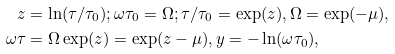<formula> <loc_0><loc_0><loc_500><loc_500>z & = \ln ( \tau / \tau _ { 0 } ) ; \omega \tau _ { 0 } = \Omega ; \tau / \tau _ { 0 } = \exp ( z ) , \Omega = \exp ( - \mu ) , \\ \omega \tau & = \Omega \exp ( z ) = \exp ( z - \mu ) , y = - \ln ( \omega \tau _ { 0 } ) ,</formula> 